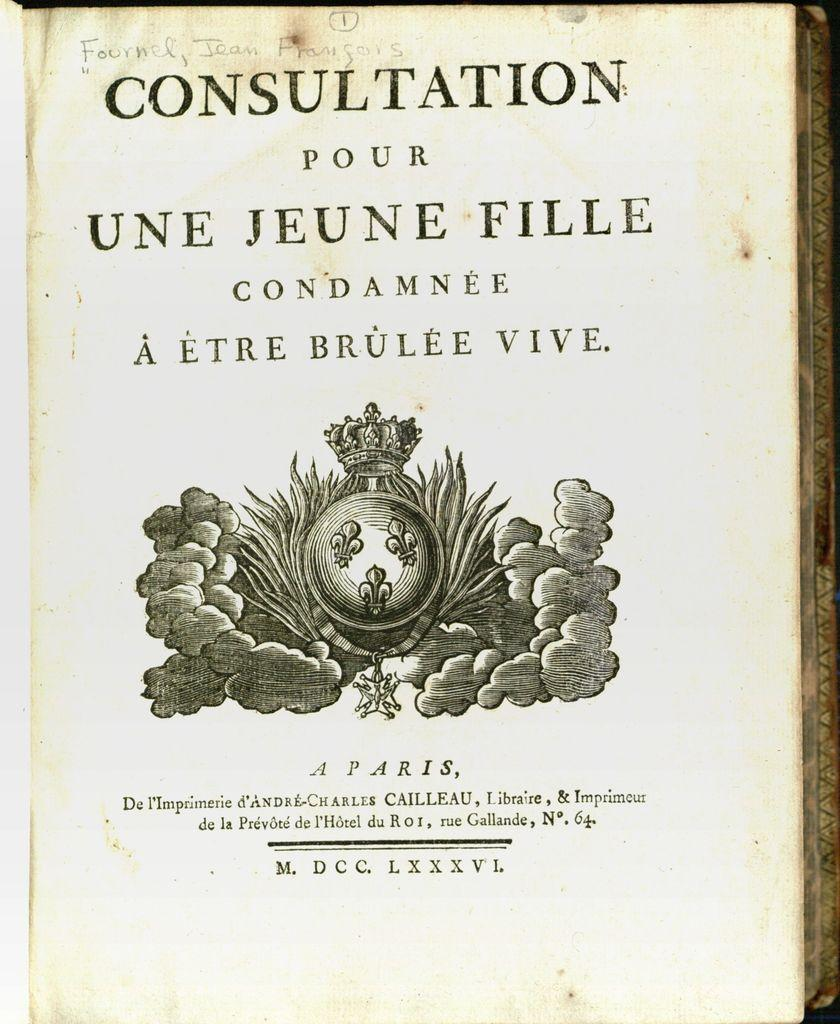<image>
Present a compact description of the photo's key features. A book is open to the first page and says Consultation. 